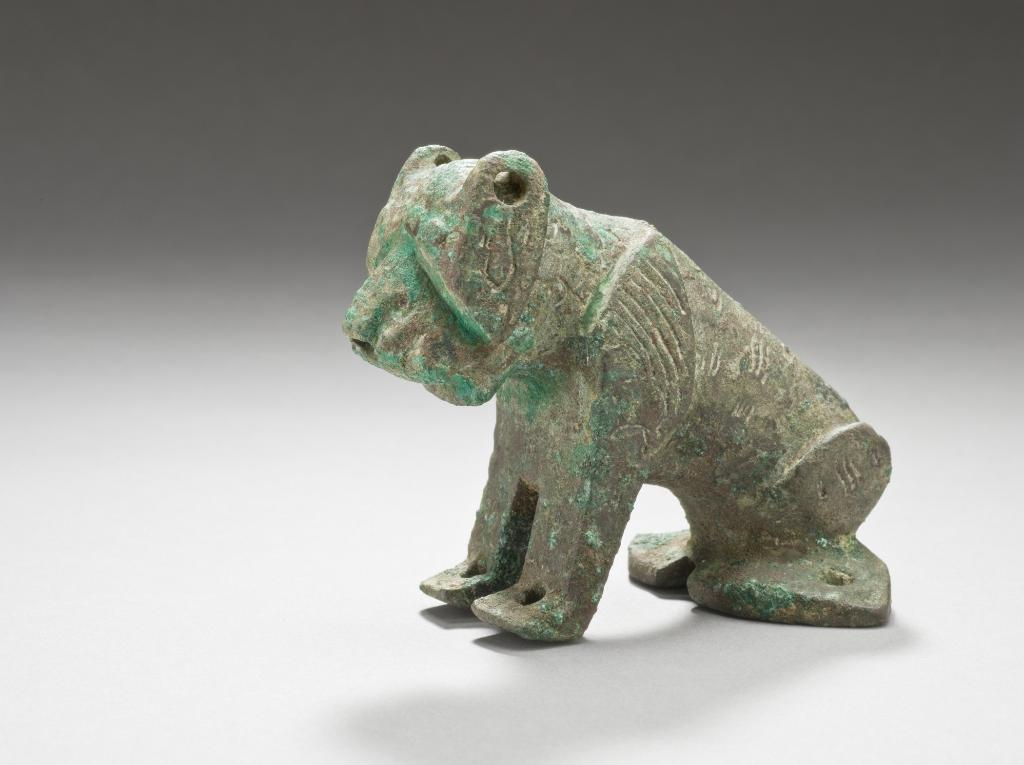What is the main subject of the image? There is a statue of a frog in the image. What is the statue placed on? The statue is on a surface. What color is the background of the image? The background of the image is grey. What type of attraction is the frog statue a part of in the image? There is no indication in the image that the frog statue is a part of any attraction. What arithmetic problem can be solved using the frog statue in the image? There is no arithmetic problem associated with the frog statue in the image. 